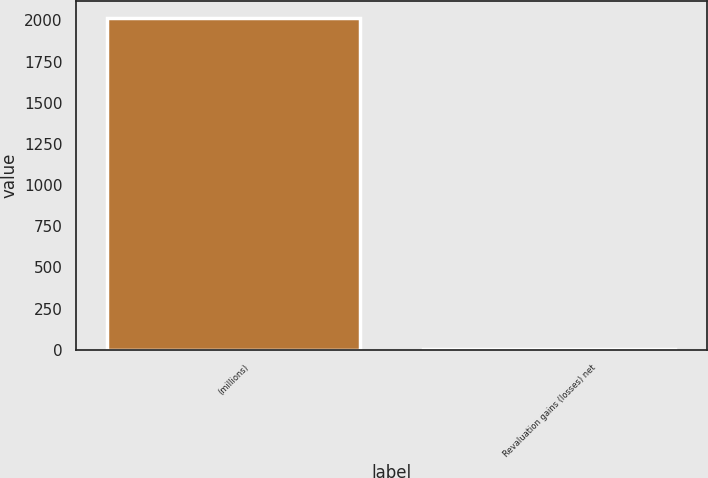<chart> <loc_0><loc_0><loc_500><loc_500><bar_chart><fcel>(millions)<fcel>Revaluation gains (losses) net<nl><fcel>2016<fcel>2.5<nl></chart> 